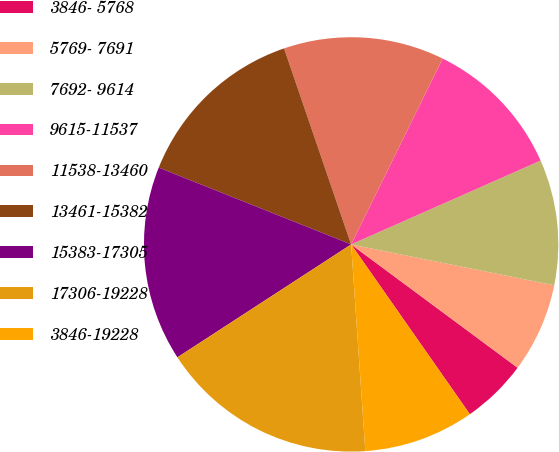<chart> <loc_0><loc_0><loc_500><loc_500><pie_chart><fcel>3846- 5768<fcel>5769- 7691<fcel>7692- 9614<fcel>9615-11537<fcel>11538-13460<fcel>13461-15382<fcel>15383-17305<fcel>17306-19228<fcel>3846-19228<nl><fcel>5.14%<fcel>6.99%<fcel>9.79%<fcel>11.09%<fcel>12.53%<fcel>13.71%<fcel>15.22%<fcel>16.92%<fcel>8.62%<nl></chart> 